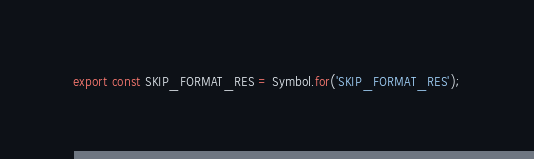<code> <loc_0><loc_0><loc_500><loc_500><_TypeScript_>
export const SKIP_FORMAT_RES = Symbol.for('SKIP_FORMAT_RES');
</code> 